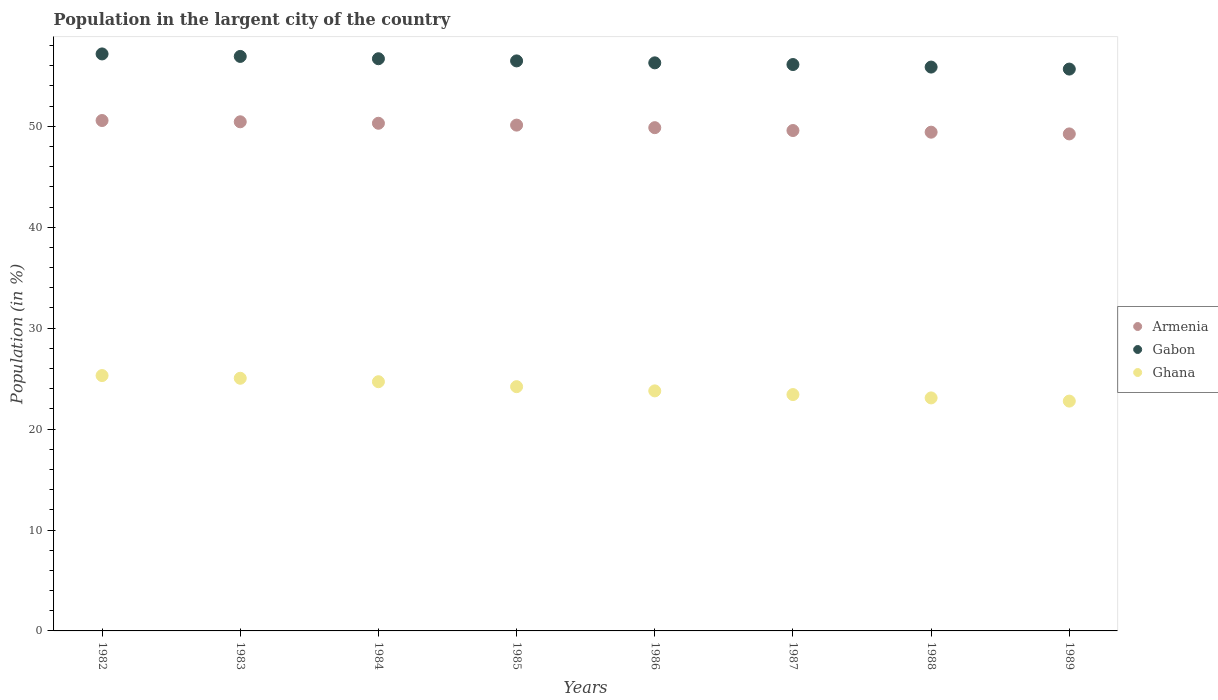What is the percentage of population in the largent city in Ghana in 1984?
Provide a succinct answer. 24.69. Across all years, what is the maximum percentage of population in the largent city in Ghana?
Your answer should be compact. 25.3. Across all years, what is the minimum percentage of population in the largent city in Gabon?
Offer a very short reply. 55.67. In which year was the percentage of population in the largent city in Ghana maximum?
Give a very brief answer. 1982. In which year was the percentage of population in the largent city in Gabon minimum?
Offer a very short reply. 1989. What is the total percentage of population in the largent city in Armenia in the graph?
Your response must be concise. 399.58. What is the difference between the percentage of population in the largent city in Armenia in 1987 and that in 1989?
Keep it short and to the point. 0.34. What is the difference between the percentage of population in the largent city in Ghana in 1985 and the percentage of population in the largent city in Armenia in 1988?
Keep it short and to the point. -25.22. What is the average percentage of population in the largent city in Armenia per year?
Offer a very short reply. 49.95. In the year 1986, what is the difference between the percentage of population in the largent city in Ghana and percentage of population in the largent city in Gabon?
Provide a short and direct response. -32.51. In how many years, is the percentage of population in the largent city in Armenia greater than 14 %?
Provide a succinct answer. 8. What is the ratio of the percentage of population in the largent city in Armenia in 1984 to that in 1985?
Keep it short and to the point. 1. Is the percentage of population in the largent city in Gabon in 1983 less than that in 1984?
Make the answer very short. No. What is the difference between the highest and the second highest percentage of population in the largent city in Gabon?
Make the answer very short. 0.25. What is the difference between the highest and the lowest percentage of population in the largent city in Ghana?
Your response must be concise. 2.53. Is the sum of the percentage of population in the largent city in Gabon in 1984 and 1985 greater than the maximum percentage of population in the largent city in Armenia across all years?
Your answer should be very brief. Yes. Does the percentage of population in the largent city in Gabon monotonically increase over the years?
Offer a terse response. No. Is the percentage of population in the largent city in Ghana strictly less than the percentage of population in the largent city in Armenia over the years?
Offer a terse response. Yes. How many dotlines are there?
Offer a very short reply. 3. How many years are there in the graph?
Keep it short and to the point. 8. What is the difference between two consecutive major ticks on the Y-axis?
Provide a succinct answer. 10. Does the graph contain any zero values?
Ensure brevity in your answer.  No. What is the title of the graph?
Provide a succinct answer. Population in the largent city of the country. Does "Eritrea" appear as one of the legend labels in the graph?
Ensure brevity in your answer.  No. What is the label or title of the Y-axis?
Provide a succinct answer. Population (in %). What is the Population (in %) in Armenia in 1982?
Keep it short and to the point. 50.58. What is the Population (in %) of Gabon in 1982?
Provide a succinct answer. 57.17. What is the Population (in %) in Ghana in 1982?
Your response must be concise. 25.3. What is the Population (in %) of Armenia in 1983?
Your response must be concise. 50.45. What is the Population (in %) in Gabon in 1983?
Keep it short and to the point. 56.93. What is the Population (in %) in Ghana in 1983?
Make the answer very short. 25.04. What is the Population (in %) in Armenia in 1984?
Ensure brevity in your answer.  50.3. What is the Population (in %) of Gabon in 1984?
Keep it short and to the point. 56.7. What is the Population (in %) in Ghana in 1984?
Provide a succinct answer. 24.69. What is the Population (in %) of Armenia in 1985?
Your answer should be compact. 50.12. What is the Population (in %) of Gabon in 1985?
Keep it short and to the point. 56.48. What is the Population (in %) of Ghana in 1985?
Ensure brevity in your answer.  24.2. What is the Population (in %) of Armenia in 1986?
Provide a succinct answer. 49.87. What is the Population (in %) of Gabon in 1986?
Provide a short and direct response. 56.29. What is the Population (in %) in Ghana in 1986?
Your answer should be compact. 23.79. What is the Population (in %) in Armenia in 1987?
Offer a very short reply. 49.59. What is the Population (in %) in Gabon in 1987?
Provide a short and direct response. 56.12. What is the Population (in %) in Ghana in 1987?
Provide a succinct answer. 23.42. What is the Population (in %) in Armenia in 1988?
Provide a succinct answer. 49.42. What is the Population (in %) in Gabon in 1988?
Your answer should be very brief. 55.87. What is the Population (in %) of Ghana in 1988?
Make the answer very short. 23.09. What is the Population (in %) of Armenia in 1989?
Offer a terse response. 49.25. What is the Population (in %) in Gabon in 1989?
Offer a terse response. 55.67. What is the Population (in %) of Ghana in 1989?
Your response must be concise. 22.77. Across all years, what is the maximum Population (in %) of Armenia?
Your answer should be very brief. 50.58. Across all years, what is the maximum Population (in %) of Gabon?
Make the answer very short. 57.17. Across all years, what is the maximum Population (in %) of Ghana?
Offer a terse response. 25.3. Across all years, what is the minimum Population (in %) of Armenia?
Offer a terse response. 49.25. Across all years, what is the minimum Population (in %) in Gabon?
Make the answer very short. 55.67. Across all years, what is the minimum Population (in %) in Ghana?
Your answer should be compact. 22.77. What is the total Population (in %) of Armenia in the graph?
Keep it short and to the point. 399.58. What is the total Population (in %) in Gabon in the graph?
Provide a succinct answer. 451.25. What is the total Population (in %) of Ghana in the graph?
Offer a terse response. 192.31. What is the difference between the Population (in %) of Armenia in 1982 and that in 1983?
Keep it short and to the point. 0.13. What is the difference between the Population (in %) of Gabon in 1982 and that in 1983?
Provide a succinct answer. 0.25. What is the difference between the Population (in %) in Ghana in 1982 and that in 1983?
Your answer should be very brief. 0.27. What is the difference between the Population (in %) of Armenia in 1982 and that in 1984?
Give a very brief answer. 0.27. What is the difference between the Population (in %) in Gabon in 1982 and that in 1984?
Keep it short and to the point. 0.48. What is the difference between the Population (in %) in Ghana in 1982 and that in 1984?
Your response must be concise. 0.61. What is the difference between the Population (in %) in Armenia in 1982 and that in 1985?
Your answer should be compact. 0.46. What is the difference between the Population (in %) in Gabon in 1982 and that in 1985?
Your answer should be very brief. 0.69. What is the difference between the Population (in %) in Ghana in 1982 and that in 1985?
Give a very brief answer. 1.1. What is the difference between the Population (in %) in Armenia in 1982 and that in 1986?
Your answer should be compact. 0.71. What is the difference between the Population (in %) in Gabon in 1982 and that in 1986?
Offer a very short reply. 0.88. What is the difference between the Population (in %) of Ghana in 1982 and that in 1986?
Keep it short and to the point. 1.52. What is the difference between the Population (in %) in Armenia in 1982 and that in 1987?
Ensure brevity in your answer.  0.99. What is the difference between the Population (in %) in Gabon in 1982 and that in 1987?
Give a very brief answer. 1.05. What is the difference between the Population (in %) in Ghana in 1982 and that in 1987?
Ensure brevity in your answer.  1.88. What is the difference between the Population (in %) of Armenia in 1982 and that in 1988?
Provide a succinct answer. 1.16. What is the difference between the Population (in %) of Gabon in 1982 and that in 1988?
Provide a succinct answer. 1.3. What is the difference between the Population (in %) of Ghana in 1982 and that in 1988?
Ensure brevity in your answer.  2.21. What is the difference between the Population (in %) in Armenia in 1982 and that in 1989?
Your response must be concise. 1.33. What is the difference between the Population (in %) in Gabon in 1982 and that in 1989?
Your answer should be compact. 1.5. What is the difference between the Population (in %) in Ghana in 1982 and that in 1989?
Your answer should be compact. 2.53. What is the difference between the Population (in %) in Armenia in 1983 and that in 1984?
Your answer should be compact. 0.15. What is the difference between the Population (in %) of Gabon in 1983 and that in 1984?
Your answer should be very brief. 0.23. What is the difference between the Population (in %) in Ghana in 1983 and that in 1984?
Keep it short and to the point. 0.34. What is the difference between the Population (in %) in Armenia in 1983 and that in 1985?
Provide a short and direct response. 0.33. What is the difference between the Population (in %) of Gabon in 1983 and that in 1985?
Offer a terse response. 0.44. What is the difference between the Population (in %) of Ghana in 1983 and that in 1985?
Offer a terse response. 0.83. What is the difference between the Population (in %) of Armenia in 1983 and that in 1986?
Provide a succinct answer. 0.58. What is the difference between the Population (in %) of Gabon in 1983 and that in 1986?
Offer a terse response. 0.64. What is the difference between the Population (in %) of Ghana in 1983 and that in 1986?
Ensure brevity in your answer.  1.25. What is the difference between the Population (in %) in Armenia in 1983 and that in 1987?
Make the answer very short. 0.86. What is the difference between the Population (in %) in Gabon in 1983 and that in 1987?
Make the answer very short. 0.8. What is the difference between the Population (in %) of Ghana in 1983 and that in 1987?
Offer a very short reply. 1.62. What is the difference between the Population (in %) of Armenia in 1983 and that in 1988?
Your answer should be compact. 1.03. What is the difference between the Population (in %) in Gabon in 1983 and that in 1988?
Give a very brief answer. 1.06. What is the difference between the Population (in %) in Ghana in 1983 and that in 1988?
Make the answer very short. 1.95. What is the difference between the Population (in %) of Armenia in 1983 and that in 1989?
Your response must be concise. 1.2. What is the difference between the Population (in %) in Gabon in 1983 and that in 1989?
Give a very brief answer. 1.25. What is the difference between the Population (in %) of Ghana in 1983 and that in 1989?
Give a very brief answer. 2.26. What is the difference between the Population (in %) in Armenia in 1984 and that in 1985?
Your response must be concise. 0.18. What is the difference between the Population (in %) in Gabon in 1984 and that in 1985?
Your response must be concise. 0.21. What is the difference between the Population (in %) of Ghana in 1984 and that in 1985?
Make the answer very short. 0.49. What is the difference between the Population (in %) of Armenia in 1984 and that in 1986?
Offer a very short reply. 0.44. What is the difference between the Population (in %) of Gabon in 1984 and that in 1986?
Offer a very short reply. 0.41. What is the difference between the Population (in %) in Ghana in 1984 and that in 1986?
Offer a terse response. 0.91. What is the difference between the Population (in %) in Armenia in 1984 and that in 1987?
Your answer should be very brief. 0.72. What is the difference between the Population (in %) in Gabon in 1984 and that in 1987?
Your response must be concise. 0.58. What is the difference between the Population (in %) of Ghana in 1984 and that in 1987?
Your response must be concise. 1.27. What is the difference between the Population (in %) of Armenia in 1984 and that in 1988?
Your answer should be compact. 0.88. What is the difference between the Population (in %) of Gabon in 1984 and that in 1988?
Offer a terse response. 0.83. What is the difference between the Population (in %) in Ghana in 1984 and that in 1988?
Ensure brevity in your answer.  1.6. What is the difference between the Population (in %) in Armenia in 1984 and that in 1989?
Give a very brief answer. 1.05. What is the difference between the Population (in %) of Gabon in 1984 and that in 1989?
Make the answer very short. 1.02. What is the difference between the Population (in %) of Ghana in 1984 and that in 1989?
Your answer should be very brief. 1.92. What is the difference between the Population (in %) of Armenia in 1985 and that in 1986?
Keep it short and to the point. 0.25. What is the difference between the Population (in %) of Gabon in 1985 and that in 1986?
Give a very brief answer. 0.19. What is the difference between the Population (in %) in Ghana in 1985 and that in 1986?
Make the answer very short. 0.42. What is the difference between the Population (in %) of Armenia in 1985 and that in 1987?
Make the answer very short. 0.54. What is the difference between the Population (in %) in Gabon in 1985 and that in 1987?
Provide a succinct answer. 0.36. What is the difference between the Population (in %) in Ghana in 1985 and that in 1987?
Provide a short and direct response. 0.78. What is the difference between the Population (in %) of Armenia in 1985 and that in 1988?
Ensure brevity in your answer.  0.7. What is the difference between the Population (in %) in Gabon in 1985 and that in 1988?
Make the answer very short. 0.61. What is the difference between the Population (in %) in Ghana in 1985 and that in 1988?
Offer a very short reply. 1.11. What is the difference between the Population (in %) of Armenia in 1985 and that in 1989?
Make the answer very short. 0.87. What is the difference between the Population (in %) of Gabon in 1985 and that in 1989?
Offer a very short reply. 0.81. What is the difference between the Population (in %) of Ghana in 1985 and that in 1989?
Your answer should be very brief. 1.43. What is the difference between the Population (in %) of Armenia in 1986 and that in 1987?
Your answer should be compact. 0.28. What is the difference between the Population (in %) of Gabon in 1986 and that in 1987?
Provide a succinct answer. 0.17. What is the difference between the Population (in %) in Ghana in 1986 and that in 1987?
Keep it short and to the point. 0.37. What is the difference between the Population (in %) of Armenia in 1986 and that in 1988?
Give a very brief answer. 0.45. What is the difference between the Population (in %) in Gabon in 1986 and that in 1988?
Provide a succinct answer. 0.42. What is the difference between the Population (in %) of Ghana in 1986 and that in 1988?
Offer a very short reply. 0.7. What is the difference between the Population (in %) of Armenia in 1986 and that in 1989?
Provide a succinct answer. 0.62. What is the difference between the Population (in %) of Gabon in 1986 and that in 1989?
Provide a short and direct response. 0.62. What is the difference between the Population (in %) in Ghana in 1986 and that in 1989?
Your answer should be very brief. 1.01. What is the difference between the Population (in %) of Armenia in 1987 and that in 1988?
Offer a very short reply. 0.16. What is the difference between the Population (in %) of Gabon in 1987 and that in 1988?
Provide a short and direct response. 0.25. What is the difference between the Population (in %) in Ghana in 1987 and that in 1988?
Keep it short and to the point. 0.33. What is the difference between the Population (in %) of Armenia in 1987 and that in 1989?
Make the answer very short. 0.34. What is the difference between the Population (in %) of Gabon in 1987 and that in 1989?
Ensure brevity in your answer.  0.45. What is the difference between the Population (in %) in Ghana in 1987 and that in 1989?
Your answer should be compact. 0.65. What is the difference between the Population (in %) in Armenia in 1988 and that in 1989?
Your answer should be compact. 0.17. What is the difference between the Population (in %) of Gabon in 1988 and that in 1989?
Provide a succinct answer. 0.2. What is the difference between the Population (in %) in Ghana in 1988 and that in 1989?
Your answer should be compact. 0.32. What is the difference between the Population (in %) of Armenia in 1982 and the Population (in %) of Gabon in 1983?
Your answer should be compact. -6.35. What is the difference between the Population (in %) of Armenia in 1982 and the Population (in %) of Ghana in 1983?
Offer a very short reply. 25.54. What is the difference between the Population (in %) of Gabon in 1982 and the Population (in %) of Ghana in 1983?
Give a very brief answer. 32.14. What is the difference between the Population (in %) of Armenia in 1982 and the Population (in %) of Gabon in 1984?
Your answer should be compact. -6.12. What is the difference between the Population (in %) in Armenia in 1982 and the Population (in %) in Ghana in 1984?
Ensure brevity in your answer.  25.88. What is the difference between the Population (in %) of Gabon in 1982 and the Population (in %) of Ghana in 1984?
Your response must be concise. 32.48. What is the difference between the Population (in %) of Armenia in 1982 and the Population (in %) of Gabon in 1985?
Your answer should be very brief. -5.91. What is the difference between the Population (in %) in Armenia in 1982 and the Population (in %) in Ghana in 1985?
Make the answer very short. 26.37. What is the difference between the Population (in %) in Gabon in 1982 and the Population (in %) in Ghana in 1985?
Offer a very short reply. 32.97. What is the difference between the Population (in %) of Armenia in 1982 and the Population (in %) of Gabon in 1986?
Your answer should be very brief. -5.71. What is the difference between the Population (in %) in Armenia in 1982 and the Population (in %) in Ghana in 1986?
Your answer should be very brief. 26.79. What is the difference between the Population (in %) in Gabon in 1982 and the Population (in %) in Ghana in 1986?
Ensure brevity in your answer.  33.39. What is the difference between the Population (in %) of Armenia in 1982 and the Population (in %) of Gabon in 1987?
Your response must be concise. -5.55. What is the difference between the Population (in %) in Armenia in 1982 and the Population (in %) in Ghana in 1987?
Provide a short and direct response. 27.16. What is the difference between the Population (in %) of Gabon in 1982 and the Population (in %) of Ghana in 1987?
Your response must be concise. 33.75. What is the difference between the Population (in %) of Armenia in 1982 and the Population (in %) of Gabon in 1988?
Provide a succinct answer. -5.3. What is the difference between the Population (in %) in Armenia in 1982 and the Population (in %) in Ghana in 1988?
Provide a short and direct response. 27.49. What is the difference between the Population (in %) in Gabon in 1982 and the Population (in %) in Ghana in 1988?
Your answer should be compact. 34.09. What is the difference between the Population (in %) in Armenia in 1982 and the Population (in %) in Gabon in 1989?
Your response must be concise. -5.1. What is the difference between the Population (in %) of Armenia in 1982 and the Population (in %) of Ghana in 1989?
Your response must be concise. 27.8. What is the difference between the Population (in %) of Gabon in 1982 and the Population (in %) of Ghana in 1989?
Provide a succinct answer. 34.4. What is the difference between the Population (in %) in Armenia in 1983 and the Population (in %) in Gabon in 1984?
Provide a short and direct response. -6.25. What is the difference between the Population (in %) in Armenia in 1983 and the Population (in %) in Ghana in 1984?
Ensure brevity in your answer.  25.76. What is the difference between the Population (in %) in Gabon in 1983 and the Population (in %) in Ghana in 1984?
Offer a terse response. 32.23. What is the difference between the Population (in %) of Armenia in 1983 and the Population (in %) of Gabon in 1985?
Keep it short and to the point. -6.03. What is the difference between the Population (in %) of Armenia in 1983 and the Population (in %) of Ghana in 1985?
Keep it short and to the point. 26.25. What is the difference between the Population (in %) in Gabon in 1983 and the Population (in %) in Ghana in 1985?
Your answer should be compact. 32.72. What is the difference between the Population (in %) of Armenia in 1983 and the Population (in %) of Gabon in 1986?
Offer a terse response. -5.84. What is the difference between the Population (in %) in Armenia in 1983 and the Population (in %) in Ghana in 1986?
Your answer should be very brief. 26.66. What is the difference between the Population (in %) of Gabon in 1983 and the Population (in %) of Ghana in 1986?
Offer a very short reply. 33.14. What is the difference between the Population (in %) of Armenia in 1983 and the Population (in %) of Gabon in 1987?
Make the answer very short. -5.67. What is the difference between the Population (in %) of Armenia in 1983 and the Population (in %) of Ghana in 1987?
Your response must be concise. 27.03. What is the difference between the Population (in %) of Gabon in 1983 and the Population (in %) of Ghana in 1987?
Keep it short and to the point. 33.51. What is the difference between the Population (in %) of Armenia in 1983 and the Population (in %) of Gabon in 1988?
Offer a terse response. -5.42. What is the difference between the Population (in %) of Armenia in 1983 and the Population (in %) of Ghana in 1988?
Provide a succinct answer. 27.36. What is the difference between the Population (in %) in Gabon in 1983 and the Population (in %) in Ghana in 1988?
Offer a terse response. 33.84. What is the difference between the Population (in %) of Armenia in 1983 and the Population (in %) of Gabon in 1989?
Ensure brevity in your answer.  -5.22. What is the difference between the Population (in %) in Armenia in 1983 and the Population (in %) in Ghana in 1989?
Provide a succinct answer. 27.68. What is the difference between the Population (in %) of Gabon in 1983 and the Population (in %) of Ghana in 1989?
Provide a succinct answer. 34.16. What is the difference between the Population (in %) in Armenia in 1984 and the Population (in %) in Gabon in 1985?
Offer a very short reply. -6.18. What is the difference between the Population (in %) of Armenia in 1984 and the Population (in %) of Ghana in 1985?
Offer a terse response. 26.1. What is the difference between the Population (in %) of Gabon in 1984 and the Population (in %) of Ghana in 1985?
Ensure brevity in your answer.  32.49. What is the difference between the Population (in %) of Armenia in 1984 and the Population (in %) of Gabon in 1986?
Your answer should be compact. -5.99. What is the difference between the Population (in %) of Armenia in 1984 and the Population (in %) of Ghana in 1986?
Your answer should be compact. 26.52. What is the difference between the Population (in %) in Gabon in 1984 and the Population (in %) in Ghana in 1986?
Ensure brevity in your answer.  32.91. What is the difference between the Population (in %) in Armenia in 1984 and the Population (in %) in Gabon in 1987?
Your answer should be very brief. -5.82. What is the difference between the Population (in %) of Armenia in 1984 and the Population (in %) of Ghana in 1987?
Your response must be concise. 26.88. What is the difference between the Population (in %) in Gabon in 1984 and the Population (in %) in Ghana in 1987?
Your response must be concise. 33.28. What is the difference between the Population (in %) in Armenia in 1984 and the Population (in %) in Gabon in 1988?
Keep it short and to the point. -5.57. What is the difference between the Population (in %) of Armenia in 1984 and the Population (in %) of Ghana in 1988?
Your answer should be compact. 27.21. What is the difference between the Population (in %) in Gabon in 1984 and the Population (in %) in Ghana in 1988?
Provide a succinct answer. 33.61. What is the difference between the Population (in %) in Armenia in 1984 and the Population (in %) in Gabon in 1989?
Make the answer very short. -5.37. What is the difference between the Population (in %) of Armenia in 1984 and the Population (in %) of Ghana in 1989?
Offer a terse response. 27.53. What is the difference between the Population (in %) in Gabon in 1984 and the Population (in %) in Ghana in 1989?
Your response must be concise. 33.93. What is the difference between the Population (in %) of Armenia in 1985 and the Population (in %) of Gabon in 1986?
Your answer should be very brief. -6.17. What is the difference between the Population (in %) in Armenia in 1985 and the Population (in %) in Ghana in 1986?
Your answer should be very brief. 26.34. What is the difference between the Population (in %) in Gabon in 1985 and the Population (in %) in Ghana in 1986?
Provide a short and direct response. 32.7. What is the difference between the Population (in %) of Armenia in 1985 and the Population (in %) of Gabon in 1987?
Your answer should be very brief. -6. What is the difference between the Population (in %) in Armenia in 1985 and the Population (in %) in Ghana in 1987?
Offer a very short reply. 26.7. What is the difference between the Population (in %) in Gabon in 1985 and the Population (in %) in Ghana in 1987?
Provide a succinct answer. 33.06. What is the difference between the Population (in %) in Armenia in 1985 and the Population (in %) in Gabon in 1988?
Make the answer very short. -5.75. What is the difference between the Population (in %) of Armenia in 1985 and the Population (in %) of Ghana in 1988?
Provide a short and direct response. 27.03. What is the difference between the Population (in %) in Gabon in 1985 and the Population (in %) in Ghana in 1988?
Keep it short and to the point. 33.39. What is the difference between the Population (in %) of Armenia in 1985 and the Population (in %) of Gabon in 1989?
Provide a succinct answer. -5.55. What is the difference between the Population (in %) in Armenia in 1985 and the Population (in %) in Ghana in 1989?
Keep it short and to the point. 27.35. What is the difference between the Population (in %) in Gabon in 1985 and the Population (in %) in Ghana in 1989?
Your response must be concise. 33.71. What is the difference between the Population (in %) in Armenia in 1986 and the Population (in %) in Gabon in 1987?
Keep it short and to the point. -6.26. What is the difference between the Population (in %) in Armenia in 1986 and the Population (in %) in Ghana in 1987?
Your answer should be compact. 26.45. What is the difference between the Population (in %) of Gabon in 1986 and the Population (in %) of Ghana in 1987?
Provide a succinct answer. 32.87. What is the difference between the Population (in %) in Armenia in 1986 and the Population (in %) in Gabon in 1988?
Offer a very short reply. -6. What is the difference between the Population (in %) of Armenia in 1986 and the Population (in %) of Ghana in 1988?
Your answer should be compact. 26.78. What is the difference between the Population (in %) in Gabon in 1986 and the Population (in %) in Ghana in 1988?
Your answer should be very brief. 33.2. What is the difference between the Population (in %) in Armenia in 1986 and the Population (in %) in Gabon in 1989?
Your answer should be very brief. -5.81. What is the difference between the Population (in %) of Armenia in 1986 and the Population (in %) of Ghana in 1989?
Your answer should be very brief. 27.09. What is the difference between the Population (in %) in Gabon in 1986 and the Population (in %) in Ghana in 1989?
Give a very brief answer. 33.52. What is the difference between the Population (in %) in Armenia in 1987 and the Population (in %) in Gabon in 1988?
Offer a terse response. -6.29. What is the difference between the Population (in %) in Armenia in 1987 and the Population (in %) in Ghana in 1988?
Make the answer very short. 26.5. What is the difference between the Population (in %) of Gabon in 1987 and the Population (in %) of Ghana in 1988?
Provide a short and direct response. 33.03. What is the difference between the Population (in %) in Armenia in 1987 and the Population (in %) in Gabon in 1989?
Make the answer very short. -6.09. What is the difference between the Population (in %) of Armenia in 1987 and the Population (in %) of Ghana in 1989?
Give a very brief answer. 26.81. What is the difference between the Population (in %) in Gabon in 1987 and the Population (in %) in Ghana in 1989?
Ensure brevity in your answer.  33.35. What is the difference between the Population (in %) in Armenia in 1988 and the Population (in %) in Gabon in 1989?
Provide a short and direct response. -6.25. What is the difference between the Population (in %) of Armenia in 1988 and the Population (in %) of Ghana in 1989?
Ensure brevity in your answer.  26.65. What is the difference between the Population (in %) in Gabon in 1988 and the Population (in %) in Ghana in 1989?
Keep it short and to the point. 33.1. What is the average Population (in %) in Armenia per year?
Ensure brevity in your answer.  49.95. What is the average Population (in %) of Gabon per year?
Ensure brevity in your answer.  56.41. What is the average Population (in %) of Ghana per year?
Make the answer very short. 24.04. In the year 1982, what is the difference between the Population (in %) in Armenia and Population (in %) in Gabon?
Make the answer very short. -6.6. In the year 1982, what is the difference between the Population (in %) in Armenia and Population (in %) in Ghana?
Give a very brief answer. 25.27. In the year 1982, what is the difference between the Population (in %) of Gabon and Population (in %) of Ghana?
Ensure brevity in your answer.  31.87. In the year 1983, what is the difference between the Population (in %) of Armenia and Population (in %) of Gabon?
Your answer should be very brief. -6.48. In the year 1983, what is the difference between the Population (in %) of Armenia and Population (in %) of Ghana?
Offer a very short reply. 25.41. In the year 1983, what is the difference between the Population (in %) in Gabon and Population (in %) in Ghana?
Ensure brevity in your answer.  31.89. In the year 1984, what is the difference between the Population (in %) of Armenia and Population (in %) of Gabon?
Make the answer very short. -6.39. In the year 1984, what is the difference between the Population (in %) in Armenia and Population (in %) in Ghana?
Offer a very short reply. 25.61. In the year 1984, what is the difference between the Population (in %) of Gabon and Population (in %) of Ghana?
Give a very brief answer. 32.01. In the year 1985, what is the difference between the Population (in %) of Armenia and Population (in %) of Gabon?
Provide a succinct answer. -6.36. In the year 1985, what is the difference between the Population (in %) of Armenia and Population (in %) of Ghana?
Offer a terse response. 25.92. In the year 1985, what is the difference between the Population (in %) in Gabon and Population (in %) in Ghana?
Make the answer very short. 32.28. In the year 1986, what is the difference between the Population (in %) in Armenia and Population (in %) in Gabon?
Give a very brief answer. -6.42. In the year 1986, what is the difference between the Population (in %) in Armenia and Population (in %) in Ghana?
Ensure brevity in your answer.  26.08. In the year 1986, what is the difference between the Population (in %) of Gabon and Population (in %) of Ghana?
Your answer should be very brief. 32.51. In the year 1987, what is the difference between the Population (in %) of Armenia and Population (in %) of Gabon?
Provide a short and direct response. -6.54. In the year 1987, what is the difference between the Population (in %) in Armenia and Population (in %) in Ghana?
Provide a succinct answer. 26.17. In the year 1987, what is the difference between the Population (in %) in Gabon and Population (in %) in Ghana?
Your answer should be compact. 32.7. In the year 1988, what is the difference between the Population (in %) in Armenia and Population (in %) in Gabon?
Make the answer very short. -6.45. In the year 1988, what is the difference between the Population (in %) in Armenia and Population (in %) in Ghana?
Ensure brevity in your answer.  26.33. In the year 1988, what is the difference between the Population (in %) in Gabon and Population (in %) in Ghana?
Make the answer very short. 32.78. In the year 1989, what is the difference between the Population (in %) in Armenia and Population (in %) in Gabon?
Ensure brevity in your answer.  -6.42. In the year 1989, what is the difference between the Population (in %) of Armenia and Population (in %) of Ghana?
Ensure brevity in your answer.  26.48. In the year 1989, what is the difference between the Population (in %) in Gabon and Population (in %) in Ghana?
Make the answer very short. 32.9. What is the ratio of the Population (in %) in Ghana in 1982 to that in 1983?
Provide a succinct answer. 1.01. What is the ratio of the Population (in %) of Armenia in 1982 to that in 1984?
Provide a short and direct response. 1.01. What is the ratio of the Population (in %) of Gabon in 1982 to that in 1984?
Offer a very short reply. 1.01. What is the ratio of the Population (in %) of Ghana in 1982 to that in 1984?
Provide a succinct answer. 1.02. What is the ratio of the Population (in %) in Armenia in 1982 to that in 1985?
Offer a very short reply. 1.01. What is the ratio of the Population (in %) in Gabon in 1982 to that in 1985?
Make the answer very short. 1.01. What is the ratio of the Population (in %) of Ghana in 1982 to that in 1985?
Your answer should be very brief. 1.05. What is the ratio of the Population (in %) in Armenia in 1982 to that in 1986?
Your response must be concise. 1.01. What is the ratio of the Population (in %) of Gabon in 1982 to that in 1986?
Make the answer very short. 1.02. What is the ratio of the Population (in %) of Ghana in 1982 to that in 1986?
Your response must be concise. 1.06. What is the ratio of the Population (in %) in Armenia in 1982 to that in 1987?
Offer a terse response. 1.02. What is the ratio of the Population (in %) in Gabon in 1982 to that in 1987?
Give a very brief answer. 1.02. What is the ratio of the Population (in %) of Ghana in 1982 to that in 1987?
Your answer should be very brief. 1.08. What is the ratio of the Population (in %) of Armenia in 1982 to that in 1988?
Offer a terse response. 1.02. What is the ratio of the Population (in %) in Gabon in 1982 to that in 1988?
Keep it short and to the point. 1.02. What is the ratio of the Population (in %) in Ghana in 1982 to that in 1988?
Provide a succinct answer. 1.1. What is the ratio of the Population (in %) in Armenia in 1982 to that in 1989?
Provide a succinct answer. 1.03. What is the ratio of the Population (in %) of Gabon in 1982 to that in 1989?
Ensure brevity in your answer.  1.03. What is the ratio of the Population (in %) of Ghana in 1982 to that in 1989?
Ensure brevity in your answer.  1.11. What is the ratio of the Population (in %) in Ghana in 1983 to that in 1984?
Provide a short and direct response. 1.01. What is the ratio of the Population (in %) in Armenia in 1983 to that in 1985?
Make the answer very short. 1.01. What is the ratio of the Population (in %) of Gabon in 1983 to that in 1985?
Offer a terse response. 1.01. What is the ratio of the Population (in %) of Ghana in 1983 to that in 1985?
Provide a short and direct response. 1.03. What is the ratio of the Population (in %) in Armenia in 1983 to that in 1986?
Provide a succinct answer. 1.01. What is the ratio of the Population (in %) of Gabon in 1983 to that in 1986?
Offer a very short reply. 1.01. What is the ratio of the Population (in %) of Ghana in 1983 to that in 1986?
Your answer should be very brief. 1.05. What is the ratio of the Population (in %) in Armenia in 1983 to that in 1987?
Provide a short and direct response. 1.02. What is the ratio of the Population (in %) of Gabon in 1983 to that in 1987?
Offer a terse response. 1.01. What is the ratio of the Population (in %) in Ghana in 1983 to that in 1987?
Your response must be concise. 1.07. What is the ratio of the Population (in %) in Armenia in 1983 to that in 1988?
Provide a succinct answer. 1.02. What is the ratio of the Population (in %) in Gabon in 1983 to that in 1988?
Your response must be concise. 1.02. What is the ratio of the Population (in %) in Ghana in 1983 to that in 1988?
Offer a very short reply. 1.08. What is the ratio of the Population (in %) in Armenia in 1983 to that in 1989?
Make the answer very short. 1.02. What is the ratio of the Population (in %) of Gabon in 1983 to that in 1989?
Provide a succinct answer. 1.02. What is the ratio of the Population (in %) of Ghana in 1983 to that in 1989?
Your answer should be very brief. 1.1. What is the ratio of the Population (in %) of Armenia in 1984 to that in 1985?
Your response must be concise. 1. What is the ratio of the Population (in %) in Gabon in 1984 to that in 1985?
Your answer should be compact. 1. What is the ratio of the Population (in %) of Ghana in 1984 to that in 1985?
Your answer should be very brief. 1.02. What is the ratio of the Population (in %) in Armenia in 1984 to that in 1986?
Provide a succinct answer. 1.01. What is the ratio of the Population (in %) of Ghana in 1984 to that in 1986?
Offer a very short reply. 1.04. What is the ratio of the Population (in %) in Armenia in 1984 to that in 1987?
Make the answer very short. 1.01. What is the ratio of the Population (in %) in Gabon in 1984 to that in 1987?
Ensure brevity in your answer.  1.01. What is the ratio of the Population (in %) of Ghana in 1984 to that in 1987?
Make the answer very short. 1.05. What is the ratio of the Population (in %) of Armenia in 1984 to that in 1988?
Keep it short and to the point. 1.02. What is the ratio of the Population (in %) in Gabon in 1984 to that in 1988?
Your response must be concise. 1.01. What is the ratio of the Population (in %) in Ghana in 1984 to that in 1988?
Ensure brevity in your answer.  1.07. What is the ratio of the Population (in %) in Armenia in 1984 to that in 1989?
Offer a very short reply. 1.02. What is the ratio of the Population (in %) of Gabon in 1984 to that in 1989?
Ensure brevity in your answer.  1.02. What is the ratio of the Population (in %) in Ghana in 1984 to that in 1989?
Ensure brevity in your answer.  1.08. What is the ratio of the Population (in %) in Gabon in 1985 to that in 1986?
Keep it short and to the point. 1. What is the ratio of the Population (in %) of Ghana in 1985 to that in 1986?
Your response must be concise. 1.02. What is the ratio of the Population (in %) in Armenia in 1985 to that in 1987?
Offer a terse response. 1.01. What is the ratio of the Population (in %) in Gabon in 1985 to that in 1987?
Offer a terse response. 1.01. What is the ratio of the Population (in %) of Ghana in 1985 to that in 1987?
Your response must be concise. 1.03. What is the ratio of the Population (in %) in Armenia in 1985 to that in 1988?
Your response must be concise. 1.01. What is the ratio of the Population (in %) of Gabon in 1985 to that in 1988?
Provide a short and direct response. 1.01. What is the ratio of the Population (in %) of Ghana in 1985 to that in 1988?
Provide a short and direct response. 1.05. What is the ratio of the Population (in %) of Armenia in 1985 to that in 1989?
Offer a terse response. 1.02. What is the ratio of the Population (in %) in Gabon in 1985 to that in 1989?
Offer a terse response. 1.01. What is the ratio of the Population (in %) of Ghana in 1985 to that in 1989?
Your answer should be very brief. 1.06. What is the ratio of the Population (in %) in Ghana in 1986 to that in 1987?
Offer a very short reply. 1.02. What is the ratio of the Population (in %) of Armenia in 1986 to that in 1988?
Make the answer very short. 1.01. What is the ratio of the Population (in %) of Gabon in 1986 to that in 1988?
Offer a very short reply. 1.01. What is the ratio of the Population (in %) in Ghana in 1986 to that in 1988?
Ensure brevity in your answer.  1.03. What is the ratio of the Population (in %) of Armenia in 1986 to that in 1989?
Make the answer very short. 1.01. What is the ratio of the Population (in %) in Gabon in 1986 to that in 1989?
Offer a very short reply. 1.01. What is the ratio of the Population (in %) of Ghana in 1986 to that in 1989?
Offer a terse response. 1.04. What is the ratio of the Population (in %) of Armenia in 1987 to that in 1988?
Make the answer very short. 1. What is the ratio of the Population (in %) of Gabon in 1987 to that in 1988?
Your response must be concise. 1. What is the ratio of the Population (in %) of Ghana in 1987 to that in 1988?
Ensure brevity in your answer.  1.01. What is the ratio of the Population (in %) in Armenia in 1987 to that in 1989?
Give a very brief answer. 1.01. What is the ratio of the Population (in %) in Ghana in 1987 to that in 1989?
Offer a terse response. 1.03. What is the ratio of the Population (in %) in Gabon in 1988 to that in 1989?
Your answer should be compact. 1. What is the ratio of the Population (in %) in Ghana in 1988 to that in 1989?
Ensure brevity in your answer.  1.01. What is the difference between the highest and the second highest Population (in %) in Armenia?
Ensure brevity in your answer.  0.13. What is the difference between the highest and the second highest Population (in %) of Gabon?
Your answer should be compact. 0.25. What is the difference between the highest and the second highest Population (in %) of Ghana?
Give a very brief answer. 0.27. What is the difference between the highest and the lowest Population (in %) in Armenia?
Offer a terse response. 1.33. What is the difference between the highest and the lowest Population (in %) of Gabon?
Your answer should be compact. 1.5. What is the difference between the highest and the lowest Population (in %) of Ghana?
Offer a terse response. 2.53. 